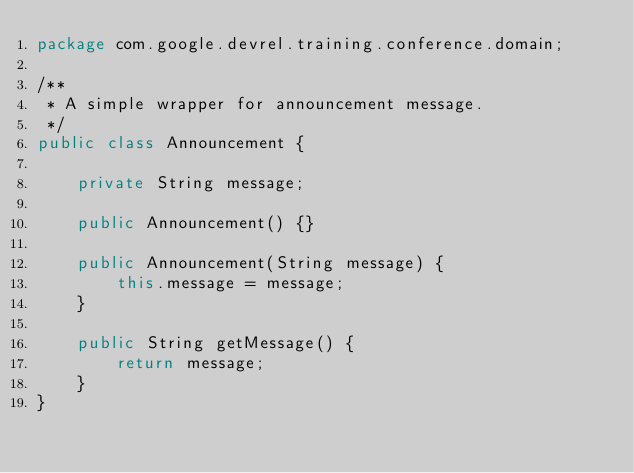Convert code to text. <code><loc_0><loc_0><loc_500><loc_500><_Java_>package com.google.devrel.training.conference.domain;

/**
 * A simple wrapper for announcement message.
 */
public class Announcement {

    private String message;

    public Announcement() {}

    public Announcement(String message) {
        this.message = message;
    }

    public String getMessage() {
        return message;
    }
}</code> 